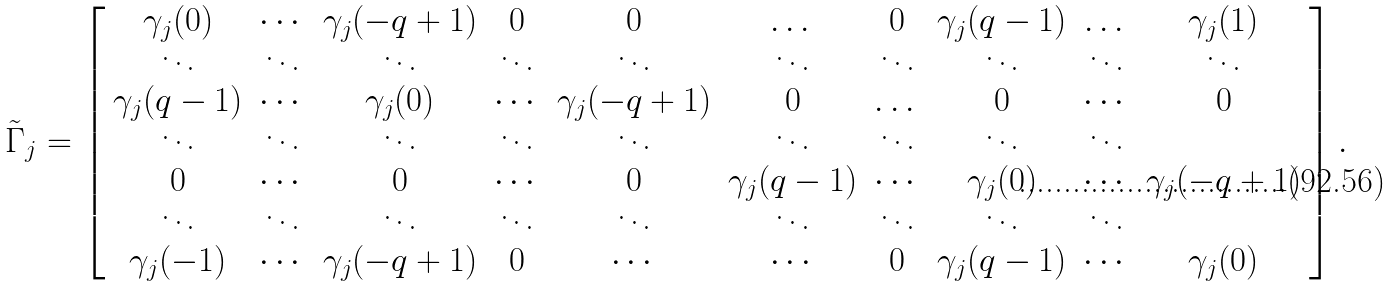Convert formula to latex. <formula><loc_0><loc_0><loc_500><loc_500>\tilde { \Gamma } _ { j } = \left [ \begin{array} { c c c c c c c c c c c c c } \gamma _ { j } ( 0 ) & \cdots & \gamma _ { j } ( - q + 1 ) & 0 & 0 & \dots & 0 & \gamma _ { j } ( q - 1 ) & \dots & \gamma _ { j } ( 1 ) \\ \ddots & \ddots & \ddots & \ddots & \ddots & \ddots & \ddots & \ddots & \ddots & \ddots \\ \gamma _ { j } ( q - 1 ) & \cdots & \gamma _ { j } ( 0 ) & \cdots & \gamma _ { j } ( - q + 1 ) & 0 & \dots & 0 & \cdots & 0 \\ \ddots & \ddots & \ddots & \ddots & \ddots & \ddots & \ddots & \ddots & \ddots \\ 0 & \cdots & 0 & \cdots & 0 & \gamma _ { j } ( q - 1 ) & \cdots & \gamma _ { j } ( 0 ) & \cdots & \gamma _ { j } ( - q + 1 ) \\ \ddots & \ddots & \ddots & \ddots & \ddots & \ddots & \ddots & \ddots & \ddots \\ \gamma _ { j } ( - 1 ) & \cdots & \gamma _ { j } ( - q + 1 ) & 0 & \cdots & \cdots & 0 & \gamma _ { j } ( q - 1 ) & \cdots & \gamma _ { j } ( 0 ) \\ \end{array} \right ] .</formula> 